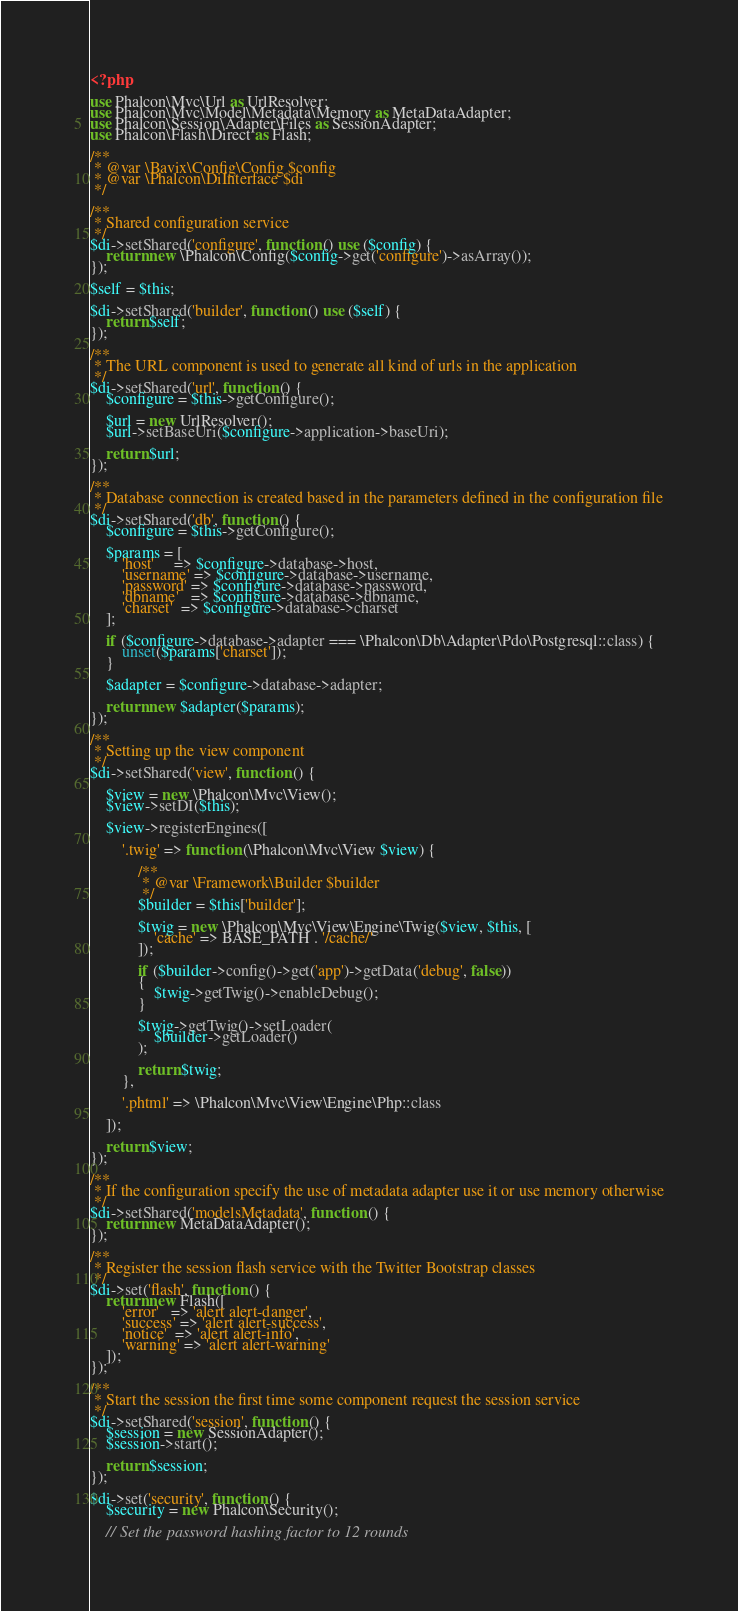Convert code to text. <code><loc_0><loc_0><loc_500><loc_500><_PHP_><?php

use Phalcon\Mvc\Url as UrlResolver;
use Phalcon\Mvc\Model\Metadata\Memory as MetaDataAdapter;
use Phalcon\Session\Adapter\Files as SessionAdapter;
use Phalcon\Flash\Direct as Flash;

/**
 * @var \Bavix\Config\Config $config
 * @var \Phalcon\DiInterface $di
 */

/**
 * Shared configuration service
 */
$di->setShared('configure', function () use ($config) {
    return new \Phalcon\Config($config->get('configure')->asArray());
});

$self = $this;

$di->setShared('builder', function () use ($self) {
    return $self;
});

/**
 * The URL component is used to generate all kind of urls in the application
 */
$di->setShared('url', function () {
    $configure = $this->getConfigure();

    $url = new UrlResolver();
    $url->setBaseUri($configure->application->baseUri);

    return $url;
});

/**
 * Database connection is created based in the parameters defined in the configuration file
 */
$di->setShared('db', function () {
    $configure = $this->getConfigure();

    $params = [
        'host'     => $configure->database->host,
        'username' => $configure->database->username,
        'password' => $configure->database->password,
        'dbname'   => $configure->database->dbname,
        'charset'  => $configure->database->charset
    ];

    if ($configure->database->adapter === \Phalcon\Db\Adapter\Pdo\Postgresql::class) {
        unset($params['charset']);
    }

    $adapter = $configure->database->adapter;

    return new $adapter($params);
});

/**
 * Setting up the view component
 */
$di->setShared('view', function () {

    $view = new \Phalcon\Mvc\View();
    $view->setDI($this);

    $view->registerEngines([

        '.twig' => function (\Phalcon\Mvc\View $view) {

            /**
             * @var \Framework\Builder $builder
             */
            $builder = $this['builder'];

            $twig = new \Phalcon\Mvc\View\Engine\Twig($view, $this, [
                'cache' => BASE_PATH . '/cache/'
            ]);

            if ($builder->config()->get('app')->getData('debug', false))
            {
                $twig->getTwig()->enableDebug();
            }

            $twig->getTwig()->setLoader(
                $builder->getLoader()
            );

            return $twig;
        },

        '.phtml' => \Phalcon\Mvc\View\Engine\Php::class

    ]);

    return $view;
});

/**
 * If the configuration specify the use of metadata adapter use it or use memory otherwise
 */
$di->setShared('modelsMetadata', function () {
    return new MetaDataAdapter();
});

/**
 * Register the session flash service with the Twitter Bootstrap classes
 */
$di->set('flash', function () {
    return new Flash([
        'error'   => 'alert alert-danger',
        'success' => 'alert alert-success',
        'notice'  => 'alert alert-info',
        'warning' => 'alert alert-warning'
    ]);
});

/**
 * Start the session the first time some component request the session service
 */
$di->setShared('session', function () {
    $session = new SessionAdapter();
    $session->start();

    return $session;
});

$di->set('security', function () {
    $security = new Phalcon\Security();

    // Set the password hashing factor to 12 rounds</code> 